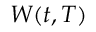<formula> <loc_0><loc_0><loc_500><loc_500>W ( t , T )</formula> 